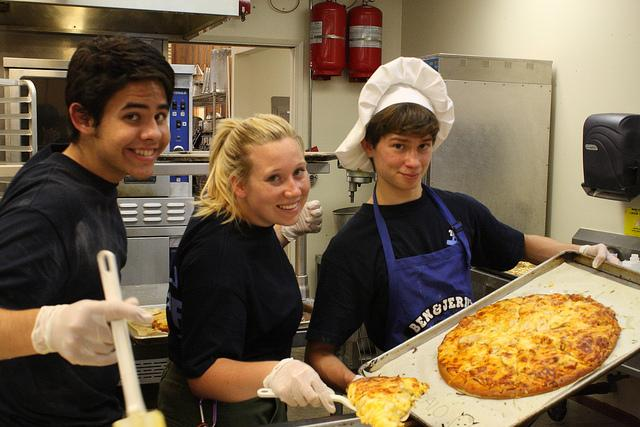How are the three people feeling in the kitchen? Please explain your reasoning. proud. They are smiling and showing off their finished pizza. 